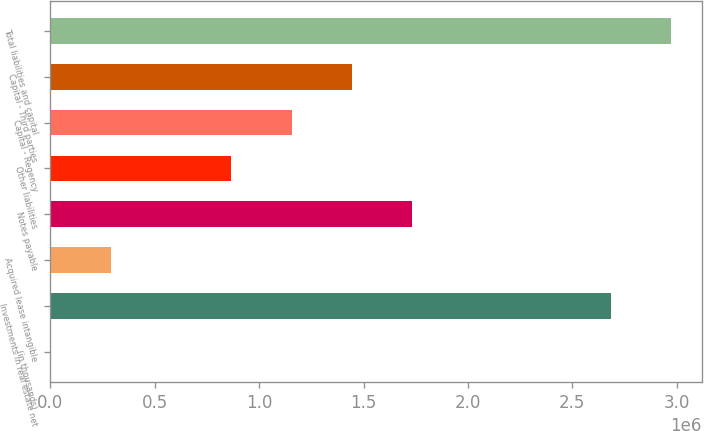Convert chart. <chart><loc_0><loc_0><loc_500><loc_500><bar_chart><fcel>(in thousands)<fcel>Investments in real estate net<fcel>Acquired lease intangible<fcel>Notes payable<fcel>Other liabilities<fcel>Capital - Regency<fcel>Capital - Third parties<fcel>Total liabilities and capital<nl><fcel>2017<fcel>2.68258e+06<fcel>290387<fcel>1.73224e+06<fcel>867128<fcel>1.1555e+06<fcel>1.44387e+06<fcel>2.97095e+06<nl></chart> 